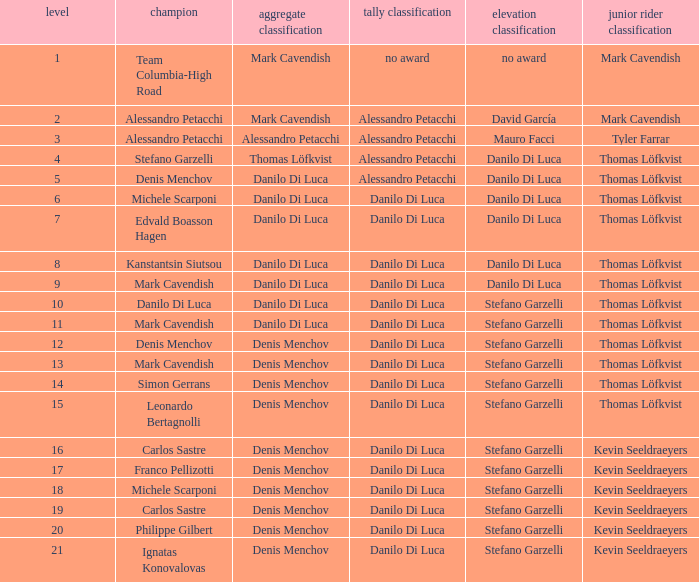When 19 is the stage who is the points classification? Danilo Di Luca. 